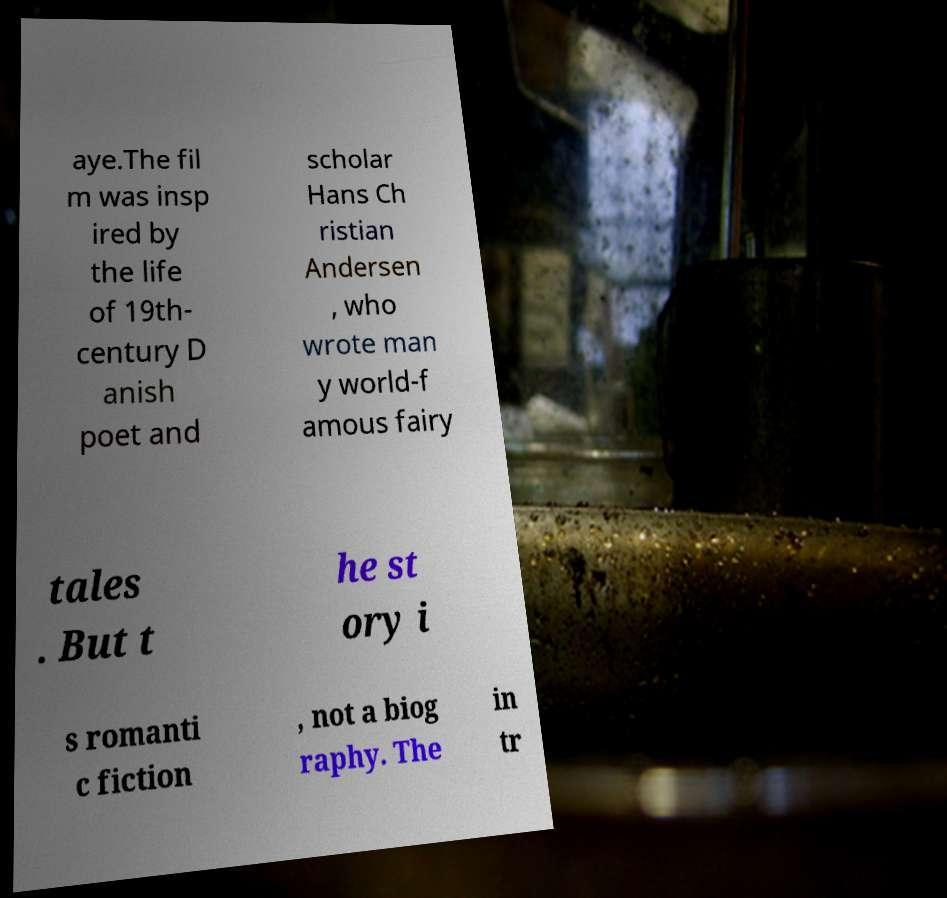There's text embedded in this image that I need extracted. Can you transcribe it verbatim? aye.The fil m was insp ired by the life of 19th- century D anish poet and scholar Hans Ch ristian Andersen , who wrote man y world-f amous fairy tales . But t he st ory i s romanti c fiction , not a biog raphy. The in tr 